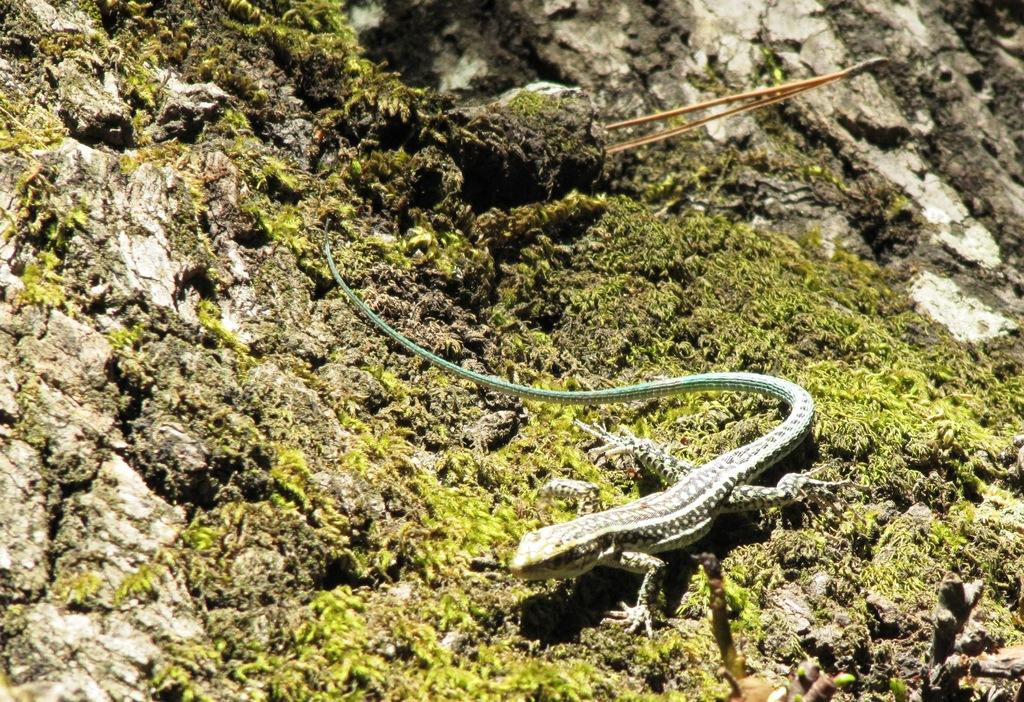What type of animal is in the image? There is a lizard in the image. Where is the lizard located? The lizard is on a stone. What else can be seen on the stone? There is a small stick on the stone. Who created the jellyfish in the image? There is no jellyfish present in the image, so the question of who created it is not applicable. 